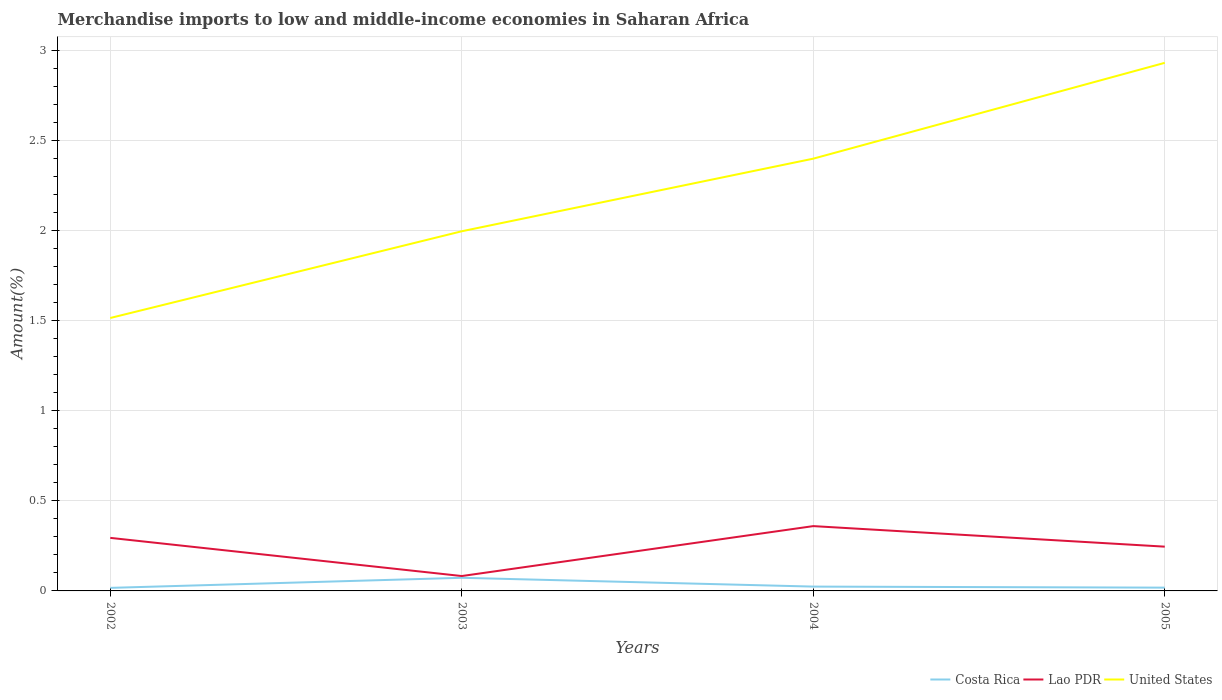Is the number of lines equal to the number of legend labels?
Provide a short and direct response. Yes. Across all years, what is the maximum percentage of amount earned from merchandise imports in Costa Rica?
Your answer should be very brief. 0.02. In which year was the percentage of amount earned from merchandise imports in United States maximum?
Your response must be concise. 2002. What is the total percentage of amount earned from merchandise imports in Costa Rica in the graph?
Give a very brief answer. 0.05. What is the difference between the highest and the second highest percentage of amount earned from merchandise imports in United States?
Your response must be concise. 1.42. How many years are there in the graph?
Give a very brief answer. 4. What is the difference between two consecutive major ticks on the Y-axis?
Your answer should be very brief. 0.5. Are the values on the major ticks of Y-axis written in scientific E-notation?
Provide a short and direct response. No. How many legend labels are there?
Offer a very short reply. 3. How are the legend labels stacked?
Your answer should be very brief. Horizontal. What is the title of the graph?
Ensure brevity in your answer.  Merchandise imports to low and middle-income economies in Saharan Africa. What is the label or title of the Y-axis?
Provide a short and direct response. Amount(%). What is the Amount(%) of Costa Rica in 2002?
Provide a succinct answer. 0.02. What is the Amount(%) in Lao PDR in 2002?
Ensure brevity in your answer.  0.29. What is the Amount(%) of United States in 2002?
Your response must be concise. 1.51. What is the Amount(%) of Costa Rica in 2003?
Make the answer very short. 0.07. What is the Amount(%) of Lao PDR in 2003?
Your answer should be very brief. 0.08. What is the Amount(%) in United States in 2003?
Provide a short and direct response. 2. What is the Amount(%) in Costa Rica in 2004?
Your response must be concise. 0.02. What is the Amount(%) of Lao PDR in 2004?
Your answer should be compact. 0.36. What is the Amount(%) of United States in 2004?
Your answer should be compact. 2.4. What is the Amount(%) of Costa Rica in 2005?
Your answer should be very brief. 0.02. What is the Amount(%) of Lao PDR in 2005?
Offer a terse response. 0.25. What is the Amount(%) in United States in 2005?
Ensure brevity in your answer.  2.93. Across all years, what is the maximum Amount(%) in Costa Rica?
Make the answer very short. 0.07. Across all years, what is the maximum Amount(%) in Lao PDR?
Offer a very short reply. 0.36. Across all years, what is the maximum Amount(%) in United States?
Make the answer very short. 2.93. Across all years, what is the minimum Amount(%) in Costa Rica?
Offer a very short reply. 0.02. Across all years, what is the minimum Amount(%) of Lao PDR?
Your answer should be very brief. 0.08. Across all years, what is the minimum Amount(%) in United States?
Give a very brief answer. 1.51. What is the total Amount(%) in Costa Rica in the graph?
Offer a terse response. 0.13. What is the total Amount(%) of United States in the graph?
Keep it short and to the point. 8.84. What is the difference between the Amount(%) in Costa Rica in 2002 and that in 2003?
Your response must be concise. -0.06. What is the difference between the Amount(%) of Lao PDR in 2002 and that in 2003?
Offer a terse response. 0.21. What is the difference between the Amount(%) of United States in 2002 and that in 2003?
Offer a terse response. -0.48. What is the difference between the Amount(%) in Costa Rica in 2002 and that in 2004?
Your answer should be very brief. -0.01. What is the difference between the Amount(%) in Lao PDR in 2002 and that in 2004?
Give a very brief answer. -0.07. What is the difference between the Amount(%) in United States in 2002 and that in 2004?
Offer a very short reply. -0.88. What is the difference between the Amount(%) of Costa Rica in 2002 and that in 2005?
Make the answer very short. -0. What is the difference between the Amount(%) of Lao PDR in 2002 and that in 2005?
Ensure brevity in your answer.  0.05. What is the difference between the Amount(%) in United States in 2002 and that in 2005?
Keep it short and to the point. -1.42. What is the difference between the Amount(%) of Costa Rica in 2003 and that in 2004?
Offer a very short reply. 0.05. What is the difference between the Amount(%) of Lao PDR in 2003 and that in 2004?
Offer a terse response. -0.28. What is the difference between the Amount(%) of United States in 2003 and that in 2004?
Make the answer very short. -0.4. What is the difference between the Amount(%) of Costa Rica in 2003 and that in 2005?
Ensure brevity in your answer.  0.05. What is the difference between the Amount(%) of Lao PDR in 2003 and that in 2005?
Give a very brief answer. -0.16. What is the difference between the Amount(%) in United States in 2003 and that in 2005?
Give a very brief answer. -0.93. What is the difference between the Amount(%) in Costa Rica in 2004 and that in 2005?
Keep it short and to the point. 0.01. What is the difference between the Amount(%) in Lao PDR in 2004 and that in 2005?
Give a very brief answer. 0.11. What is the difference between the Amount(%) of United States in 2004 and that in 2005?
Keep it short and to the point. -0.53. What is the difference between the Amount(%) in Costa Rica in 2002 and the Amount(%) in Lao PDR in 2003?
Offer a very short reply. -0.07. What is the difference between the Amount(%) in Costa Rica in 2002 and the Amount(%) in United States in 2003?
Keep it short and to the point. -1.98. What is the difference between the Amount(%) in Lao PDR in 2002 and the Amount(%) in United States in 2003?
Keep it short and to the point. -1.7. What is the difference between the Amount(%) in Costa Rica in 2002 and the Amount(%) in Lao PDR in 2004?
Offer a very short reply. -0.34. What is the difference between the Amount(%) of Costa Rica in 2002 and the Amount(%) of United States in 2004?
Keep it short and to the point. -2.38. What is the difference between the Amount(%) in Lao PDR in 2002 and the Amount(%) in United States in 2004?
Keep it short and to the point. -2.1. What is the difference between the Amount(%) of Costa Rica in 2002 and the Amount(%) of Lao PDR in 2005?
Give a very brief answer. -0.23. What is the difference between the Amount(%) of Costa Rica in 2002 and the Amount(%) of United States in 2005?
Offer a very short reply. -2.91. What is the difference between the Amount(%) in Lao PDR in 2002 and the Amount(%) in United States in 2005?
Ensure brevity in your answer.  -2.64. What is the difference between the Amount(%) in Costa Rica in 2003 and the Amount(%) in Lao PDR in 2004?
Offer a terse response. -0.29. What is the difference between the Amount(%) in Costa Rica in 2003 and the Amount(%) in United States in 2004?
Make the answer very short. -2.33. What is the difference between the Amount(%) of Lao PDR in 2003 and the Amount(%) of United States in 2004?
Provide a short and direct response. -2.32. What is the difference between the Amount(%) in Costa Rica in 2003 and the Amount(%) in Lao PDR in 2005?
Your response must be concise. -0.17. What is the difference between the Amount(%) of Costa Rica in 2003 and the Amount(%) of United States in 2005?
Your answer should be compact. -2.86. What is the difference between the Amount(%) of Lao PDR in 2003 and the Amount(%) of United States in 2005?
Provide a succinct answer. -2.85. What is the difference between the Amount(%) of Costa Rica in 2004 and the Amount(%) of Lao PDR in 2005?
Your answer should be very brief. -0.22. What is the difference between the Amount(%) of Costa Rica in 2004 and the Amount(%) of United States in 2005?
Provide a short and direct response. -2.91. What is the difference between the Amount(%) in Lao PDR in 2004 and the Amount(%) in United States in 2005?
Offer a very short reply. -2.57. What is the average Amount(%) in Costa Rica per year?
Give a very brief answer. 0.03. What is the average Amount(%) of Lao PDR per year?
Your answer should be very brief. 0.25. What is the average Amount(%) in United States per year?
Make the answer very short. 2.21. In the year 2002, what is the difference between the Amount(%) of Costa Rica and Amount(%) of Lao PDR?
Your answer should be very brief. -0.28. In the year 2002, what is the difference between the Amount(%) of Costa Rica and Amount(%) of United States?
Ensure brevity in your answer.  -1.5. In the year 2002, what is the difference between the Amount(%) in Lao PDR and Amount(%) in United States?
Ensure brevity in your answer.  -1.22. In the year 2003, what is the difference between the Amount(%) of Costa Rica and Amount(%) of Lao PDR?
Make the answer very short. -0.01. In the year 2003, what is the difference between the Amount(%) of Costa Rica and Amount(%) of United States?
Make the answer very short. -1.92. In the year 2003, what is the difference between the Amount(%) of Lao PDR and Amount(%) of United States?
Ensure brevity in your answer.  -1.91. In the year 2004, what is the difference between the Amount(%) of Costa Rica and Amount(%) of Lao PDR?
Keep it short and to the point. -0.34. In the year 2004, what is the difference between the Amount(%) in Costa Rica and Amount(%) in United States?
Your answer should be very brief. -2.37. In the year 2004, what is the difference between the Amount(%) in Lao PDR and Amount(%) in United States?
Provide a short and direct response. -2.04. In the year 2005, what is the difference between the Amount(%) of Costa Rica and Amount(%) of Lao PDR?
Offer a terse response. -0.23. In the year 2005, what is the difference between the Amount(%) in Costa Rica and Amount(%) in United States?
Your response must be concise. -2.91. In the year 2005, what is the difference between the Amount(%) in Lao PDR and Amount(%) in United States?
Offer a very short reply. -2.68. What is the ratio of the Amount(%) in Costa Rica in 2002 to that in 2003?
Keep it short and to the point. 0.23. What is the ratio of the Amount(%) of Lao PDR in 2002 to that in 2003?
Provide a succinct answer. 3.57. What is the ratio of the Amount(%) in United States in 2002 to that in 2003?
Provide a short and direct response. 0.76. What is the ratio of the Amount(%) in Costa Rica in 2002 to that in 2004?
Keep it short and to the point. 0.7. What is the ratio of the Amount(%) of Lao PDR in 2002 to that in 2004?
Ensure brevity in your answer.  0.82. What is the ratio of the Amount(%) of United States in 2002 to that in 2004?
Keep it short and to the point. 0.63. What is the ratio of the Amount(%) in Lao PDR in 2002 to that in 2005?
Offer a very short reply. 1.2. What is the ratio of the Amount(%) in United States in 2002 to that in 2005?
Ensure brevity in your answer.  0.52. What is the ratio of the Amount(%) in Costa Rica in 2003 to that in 2004?
Keep it short and to the point. 3.03. What is the ratio of the Amount(%) in Lao PDR in 2003 to that in 2004?
Keep it short and to the point. 0.23. What is the ratio of the Amount(%) in United States in 2003 to that in 2004?
Make the answer very short. 0.83. What is the ratio of the Amount(%) in Costa Rica in 2003 to that in 2005?
Keep it short and to the point. 4.01. What is the ratio of the Amount(%) of Lao PDR in 2003 to that in 2005?
Your answer should be very brief. 0.34. What is the ratio of the Amount(%) of United States in 2003 to that in 2005?
Your answer should be very brief. 0.68. What is the ratio of the Amount(%) of Costa Rica in 2004 to that in 2005?
Keep it short and to the point. 1.32. What is the ratio of the Amount(%) in Lao PDR in 2004 to that in 2005?
Offer a terse response. 1.46. What is the ratio of the Amount(%) of United States in 2004 to that in 2005?
Offer a very short reply. 0.82. What is the difference between the highest and the second highest Amount(%) in Costa Rica?
Your answer should be compact. 0.05. What is the difference between the highest and the second highest Amount(%) of Lao PDR?
Provide a short and direct response. 0.07. What is the difference between the highest and the second highest Amount(%) in United States?
Your answer should be very brief. 0.53. What is the difference between the highest and the lowest Amount(%) of Costa Rica?
Offer a terse response. 0.06. What is the difference between the highest and the lowest Amount(%) in Lao PDR?
Ensure brevity in your answer.  0.28. What is the difference between the highest and the lowest Amount(%) of United States?
Offer a terse response. 1.42. 